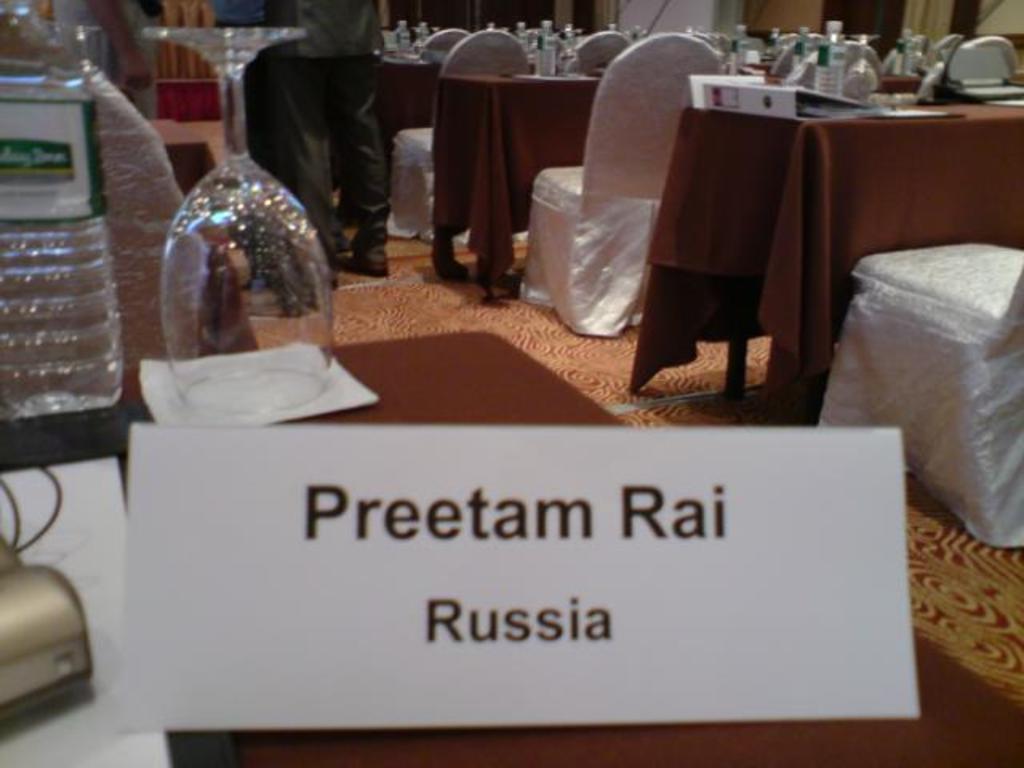Could you give a brief overview of what you see in this image? We can able to see a tables and chairs in this picture. On this tables there are bottles, file, card and glasses. Far this person is standing beside this table. 